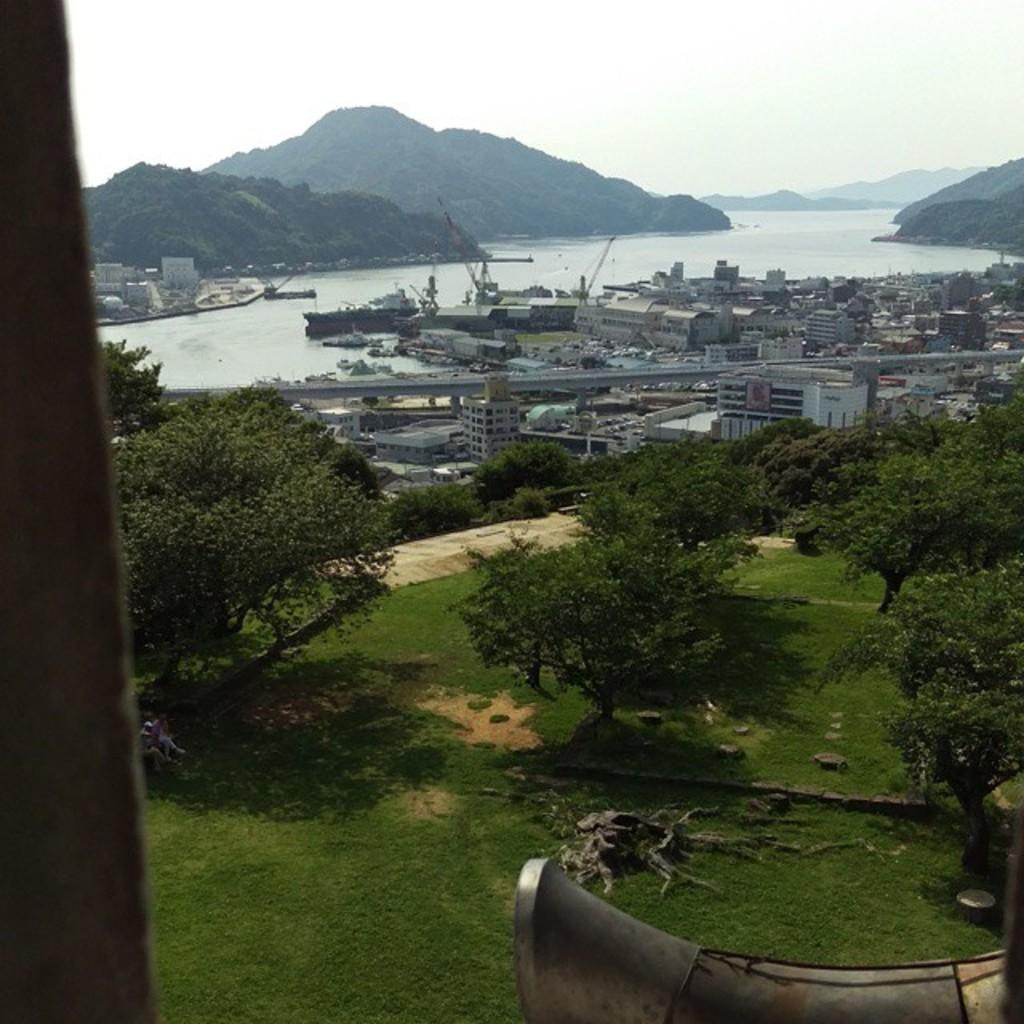Can you describe this image briefly? In this image we can see there is a pillar, in front of the pillar there are trees and an object. And there are buildings, ship, water, mountains and the sky. 